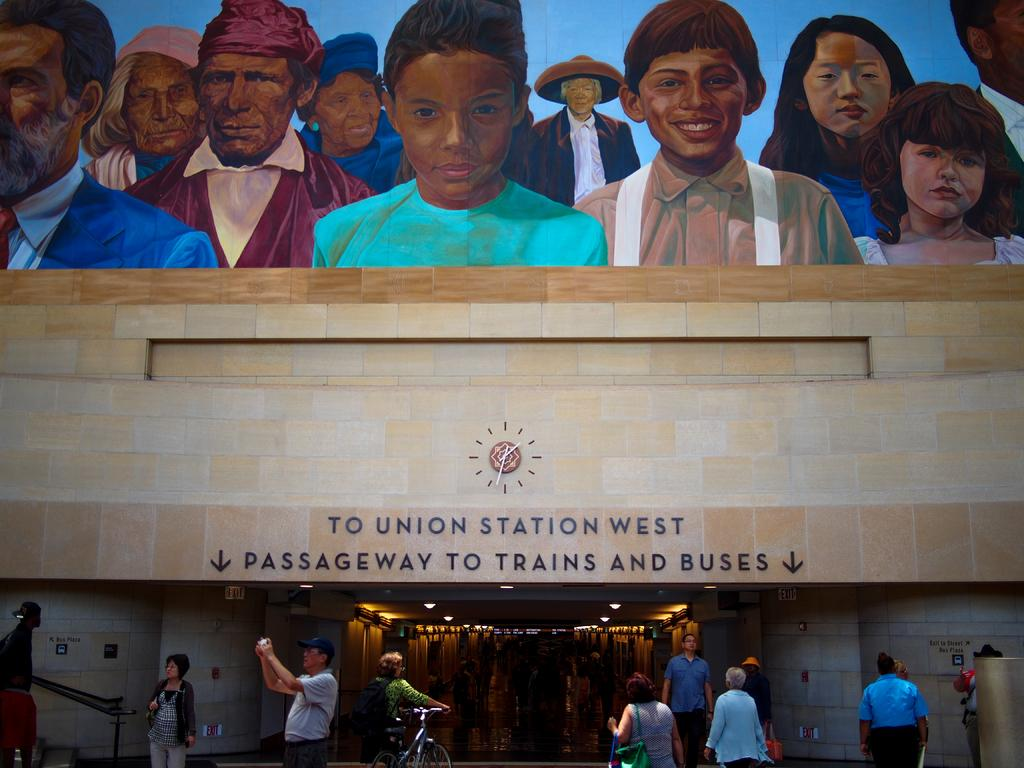Who is present at the bottom of the image? There are people at the bottom of the image. What structure can be seen in the image? There is a building in the image. What is written or displayed on the building? The building has some text on it. What activity are the people engaged in? There is a group of people painting on the building. What type of lunch is being served to the army in the image? There is no army or lunch present in the image; it features a group of people painting on a building. What emotion is being expressed by the people in the image? The image does not depict any specific emotion; it shows people painting on a building. 